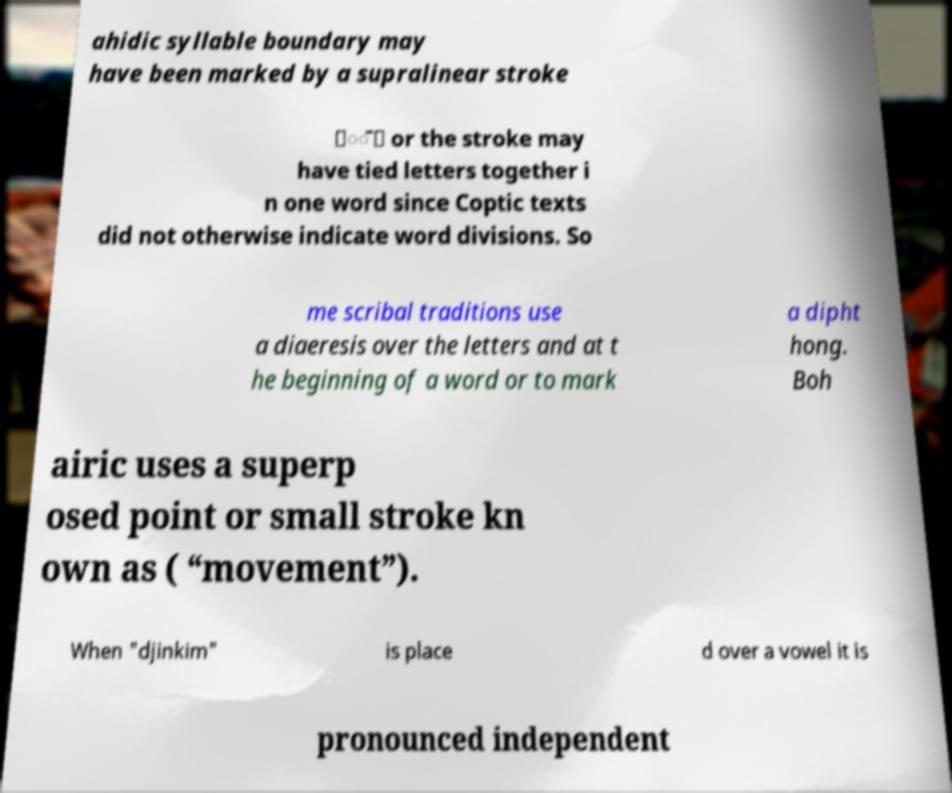Could you assist in decoding the text presented in this image and type it out clearly? ahidic syllable boundary may have been marked by a supralinear stroke ⟨◌̄⟩ or the stroke may have tied letters together i n one word since Coptic texts did not otherwise indicate word divisions. So me scribal traditions use a diaeresis over the letters and at t he beginning of a word or to mark a dipht hong. Boh airic uses a superp osed point or small stroke kn own as ( “movement”). When "djinkim" is place d over a vowel it is pronounced independent 